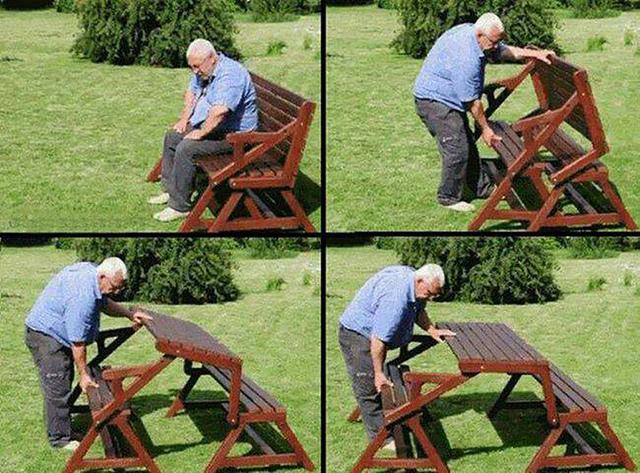Is it a metal bench?
Concise answer only. No. Do these pictures show you good instructions on how to convert the bench?
Concise answer only. Yes. The bench folds out into what?
Give a very brief answer. Table. 